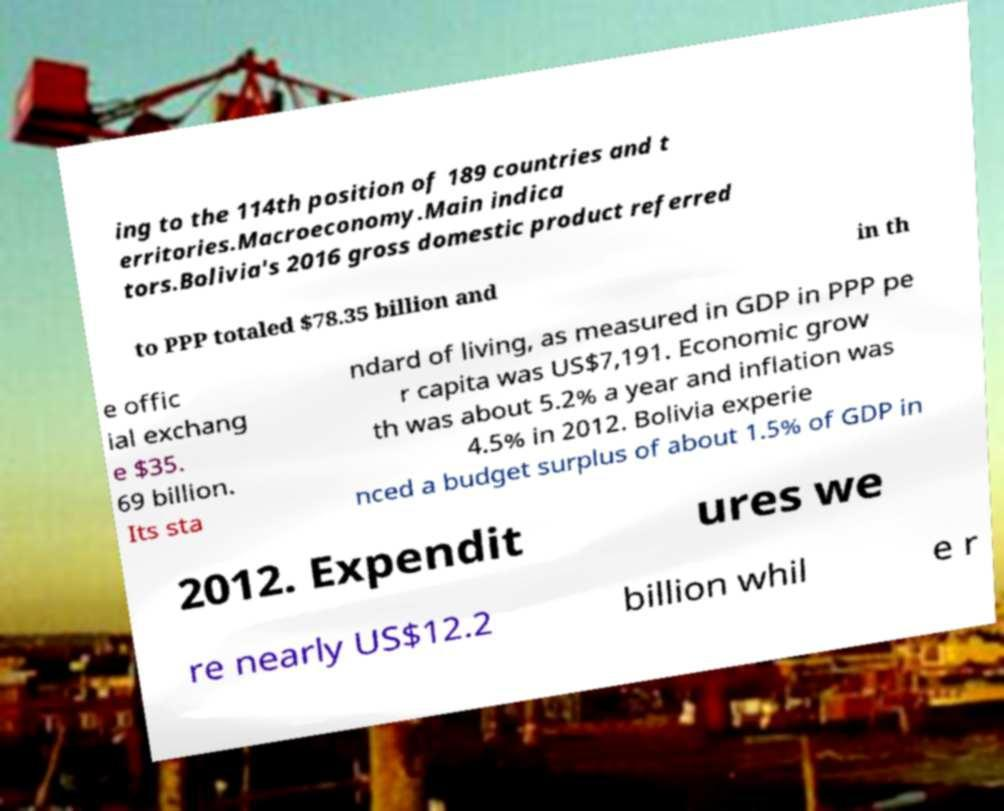For documentation purposes, I need the text within this image transcribed. Could you provide that? ing to the 114th position of 189 countries and t erritories.Macroeconomy.Main indica tors.Bolivia's 2016 gross domestic product referred to PPP totaled $78.35 billion and in th e offic ial exchang e $35. 69 billion. Its sta ndard of living, as measured in GDP in PPP pe r capita was US$7,191. Economic grow th was about 5.2% a year and inflation was 4.5% in 2012. Bolivia experie nced a budget surplus of about 1.5% of GDP in 2012. Expendit ures we re nearly US$12.2 billion whil e r 